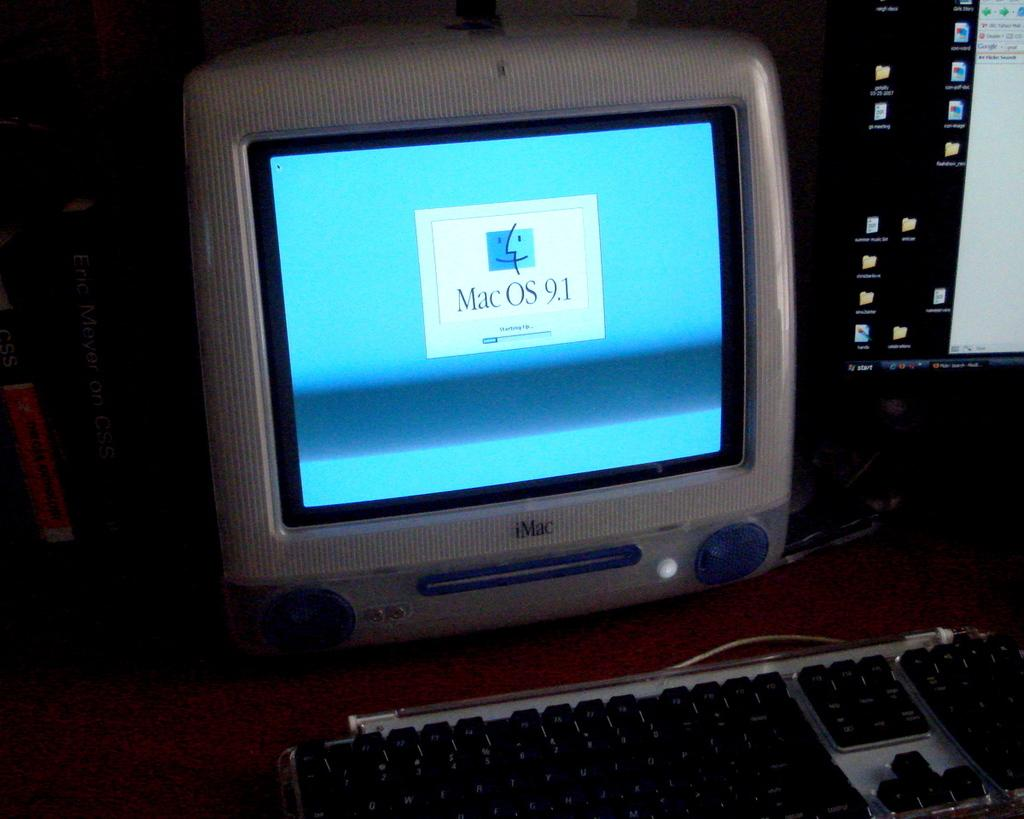<image>
Provide a brief description of the given image. Mac OS 9.1 can be used on this computer. 